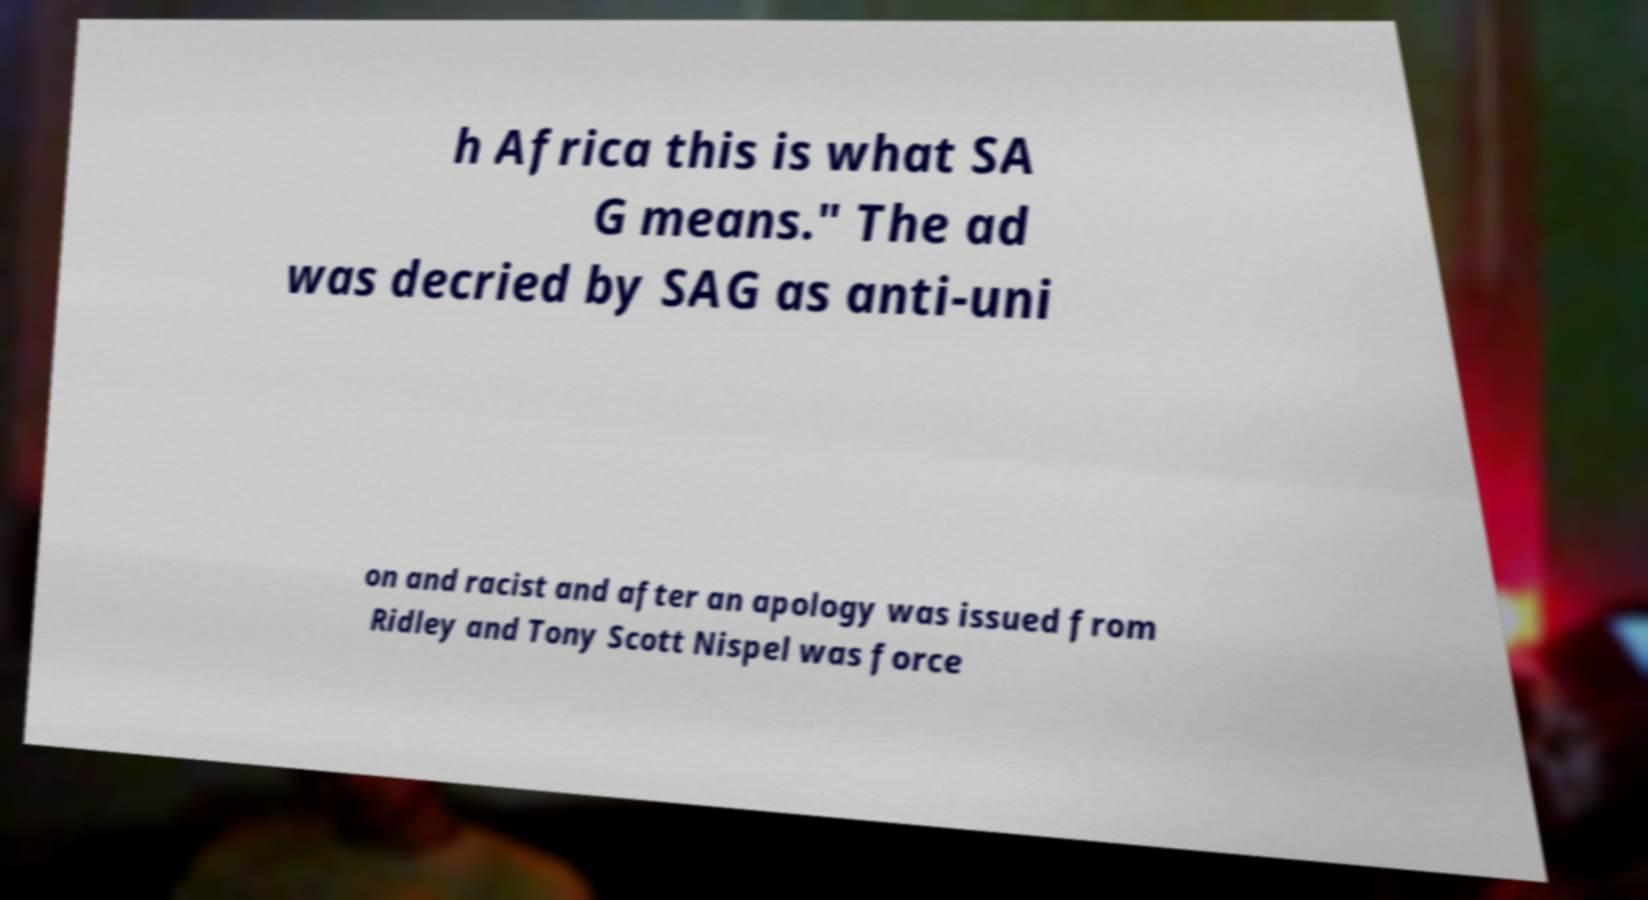For documentation purposes, I need the text within this image transcribed. Could you provide that? h Africa this is what SA G means." The ad was decried by SAG as anti-uni on and racist and after an apology was issued from Ridley and Tony Scott Nispel was force 